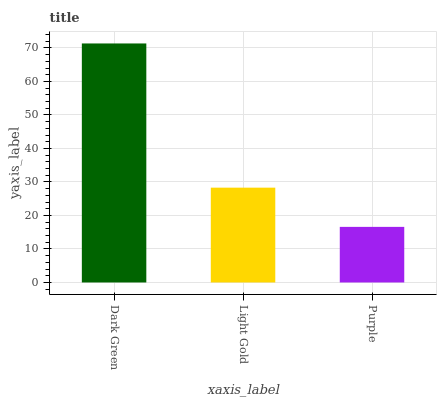Is Purple the minimum?
Answer yes or no. Yes. Is Dark Green the maximum?
Answer yes or no. Yes. Is Light Gold the minimum?
Answer yes or no. No. Is Light Gold the maximum?
Answer yes or no. No. Is Dark Green greater than Light Gold?
Answer yes or no. Yes. Is Light Gold less than Dark Green?
Answer yes or no. Yes. Is Light Gold greater than Dark Green?
Answer yes or no. No. Is Dark Green less than Light Gold?
Answer yes or no. No. Is Light Gold the high median?
Answer yes or no. Yes. Is Light Gold the low median?
Answer yes or no. Yes. Is Dark Green the high median?
Answer yes or no. No. Is Dark Green the low median?
Answer yes or no. No. 